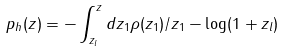<formula> <loc_0><loc_0><loc_500><loc_500>p _ { h } ( z ) = - \int _ { z _ { l } } ^ { z } d z _ { 1 } \rho ( z _ { 1 } ) / z _ { 1 } - \log ( 1 + z _ { l } )</formula> 